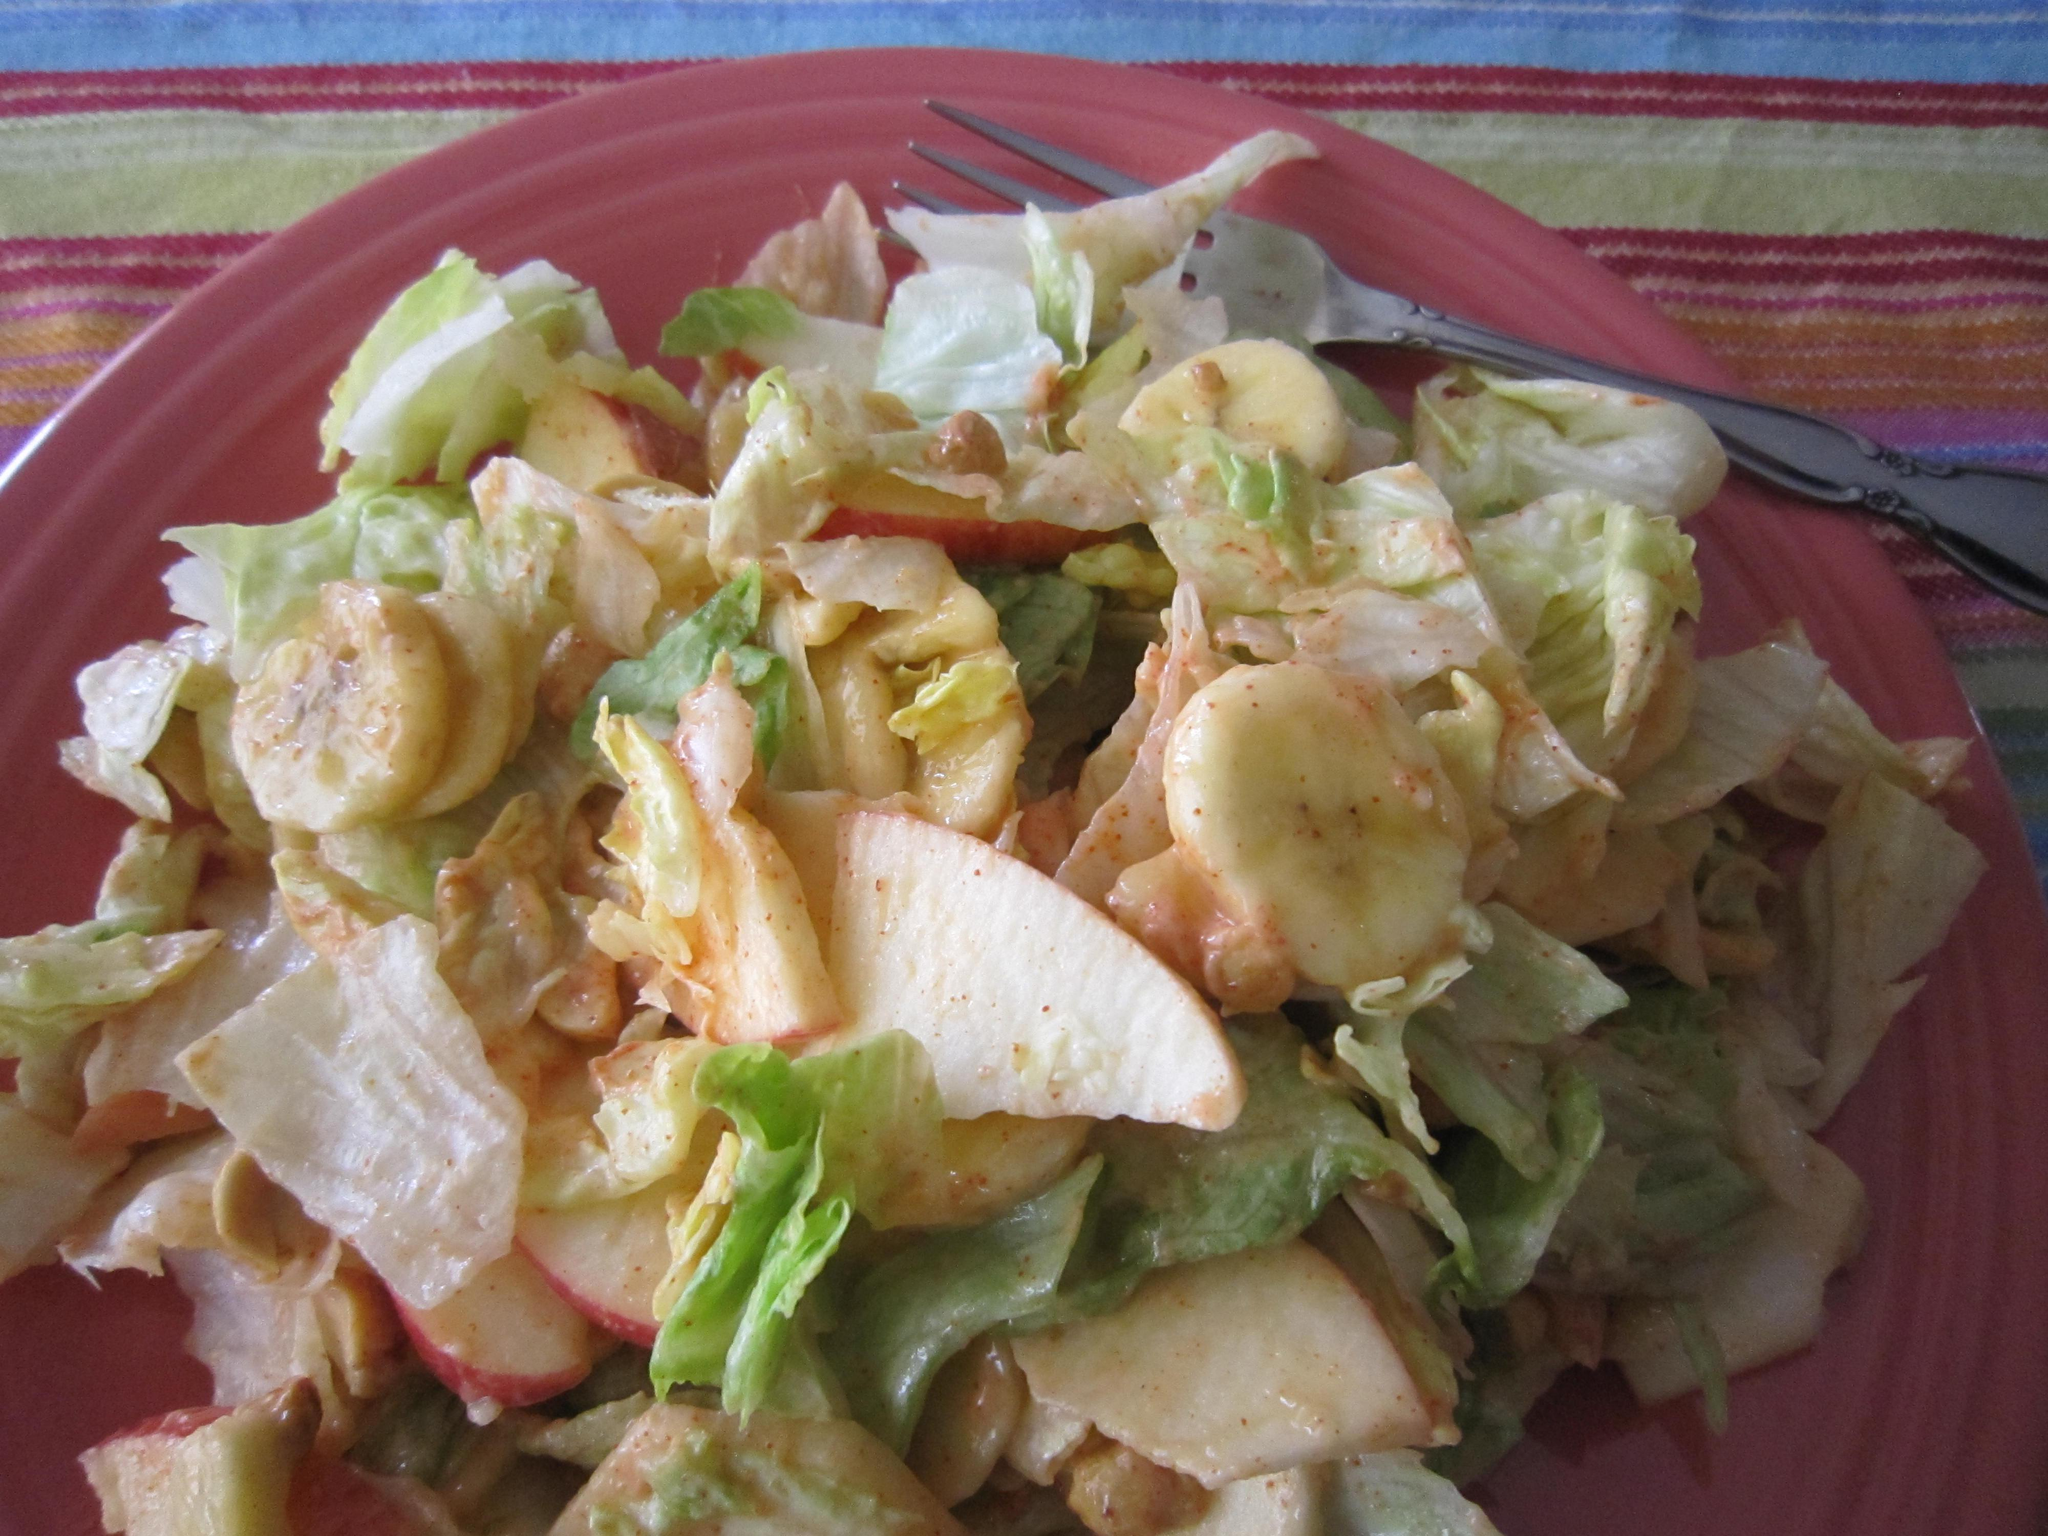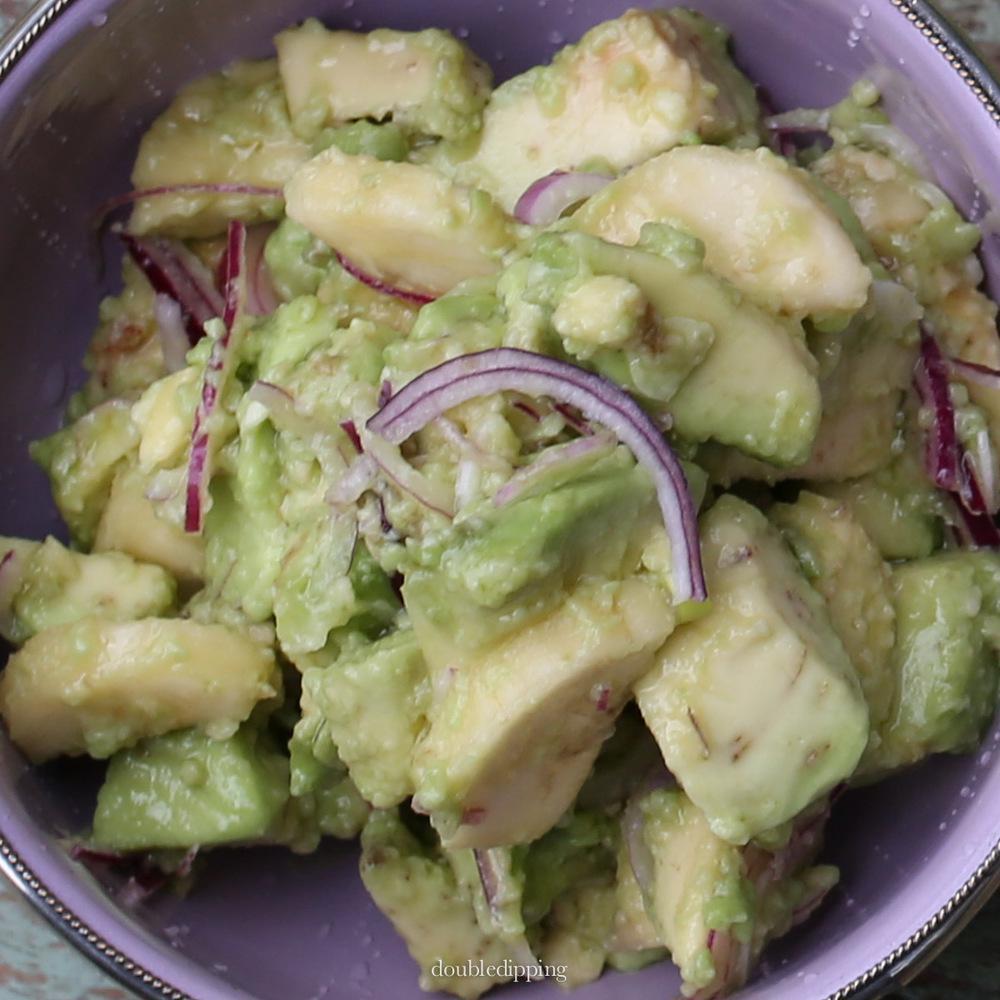The first image is the image on the left, the second image is the image on the right. Analyze the images presented: Is the assertion "One image shows ingredients sitting on a bed of green lettuce leaves on a dish." valid? Answer yes or no. No. The first image is the image on the left, the second image is the image on the right. Given the left and right images, does the statement "In at least one image there is a salad on a plate with apple and sliced red onions." hold true? Answer yes or no. Yes. 